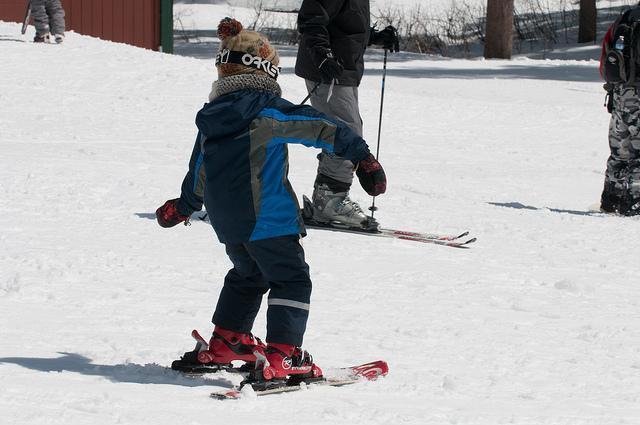How many people are there?
Give a very brief answer. 3. How many colors is the dogs fur?
Give a very brief answer. 0. 